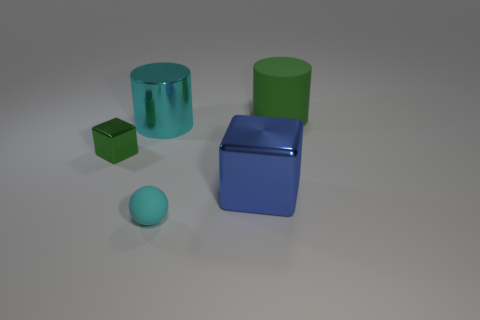What is the color of the block that is the same size as the green cylinder?
Offer a very short reply. Blue. Do the small green metallic thing and the big cyan thing have the same shape?
Provide a succinct answer. No. What is the material of the green thing that is to the left of the large green thing?
Your answer should be very brief. Metal. What color is the tiny block?
Your answer should be compact. Green. Is the size of the green thing that is in front of the cyan shiny cylinder the same as the cube that is right of the large cyan thing?
Ensure brevity in your answer.  No. There is a thing that is on the left side of the tiny cyan rubber ball and in front of the large cyan metallic object; what is its size?
Provide a short and direct response. Small. What is the color of the other large matte object that is the same shape as the big cyan object?
Provide a succinct answer. Green. Is the number of large cyan shiny things that are behind the big cyan shiny thing greater than the number of green matte cylinders in front of the tiny sphere?
Your response must be concise. No. How many other objects are the same shape as the big cyan thing?
Your answer should be compact. 1. There is a cylinder that is in front of the large rubber cylinder; is there a tiny green metal thing that is in front of it?
Provide a succinct answer. Yes. 